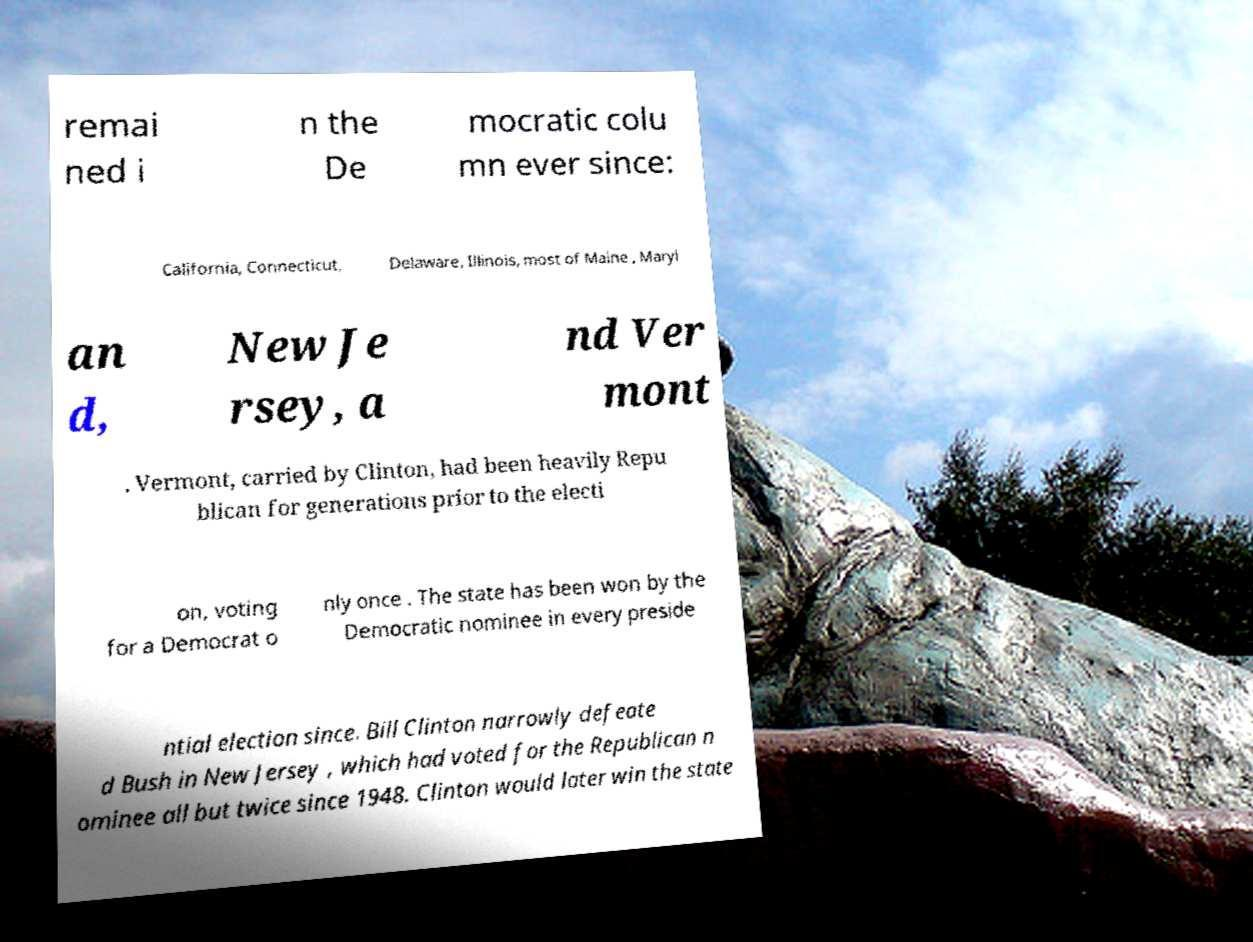Please identify and transcribe the text found in this image. remai ned i n the De mocratic colu mn ever since: California, Connecticut, Delaware, Illinois, most of Maine , Maryl an d, New Je rsey, a nd Ver mont . Vermont, carried by Clinton, had been heavily Repu blican for generations prior to the electi on, voting for a Democrat o nly once . The state has been won by the Democratic nominee in every preside ntial election since. Bill Clinton narrowly defeate d Bush in New Jersey , which had voted for the Republican n ominee all but twice since 1948. Clinton would later win the state 